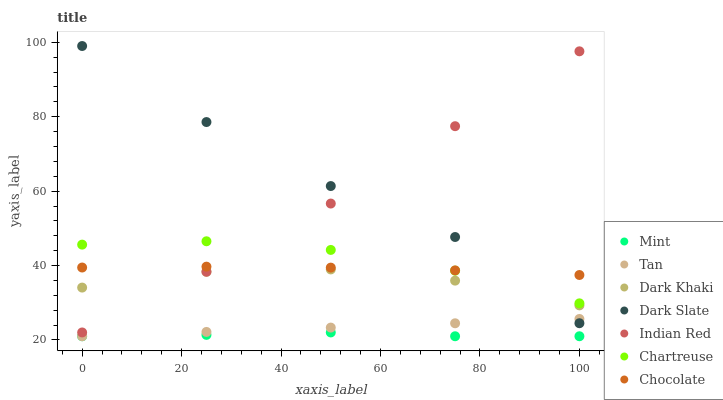Does Mint have the minimum area under the curve?
Answer yes or no. Yes. Does Dark Slate have the maximum area under the curve?
Answer yes or no. Yes. Does Dark Khaki have the minimum area under the curve?
Answer yes or no. No. Does Dark Khaki have the maximum area under the curve?
Answer yes or no. No. Is Tan the smoothest?
Answer yes or no. Yes. Is Dark Slate the roughest?
Answer yes or no. Yes. Is Dark Khaki the smoothest?
Answer yes or no. No. Is Dark Khaki the roughest?
Answer yes or no. No. Does Tan have the lowest value?
Answer yes or no. Yes. Does Dark Khaki have the lowest value?
Answer yes or no. No. Does Dark Slate have the highest value?
Answer yes or no. Yes. Does Dark Khaki have the highest value?
Answer yes or no. No. Is Tan less than Dark Khaki?
Answer yes or no. Yes. Is Chartreuse greater than Mint?
Answer yes or no. Yes. Does Indian Red intersect Dark Khaki?
Answer yes or no. Yes. Is Indian Red less than Dark Khaki?
Answer yes or no. No. Is Indian Red greater than Dark Khaki?
Answer yes or no. No. Does Tan intersect Dark Khaki?
Answer yes or no. No. 